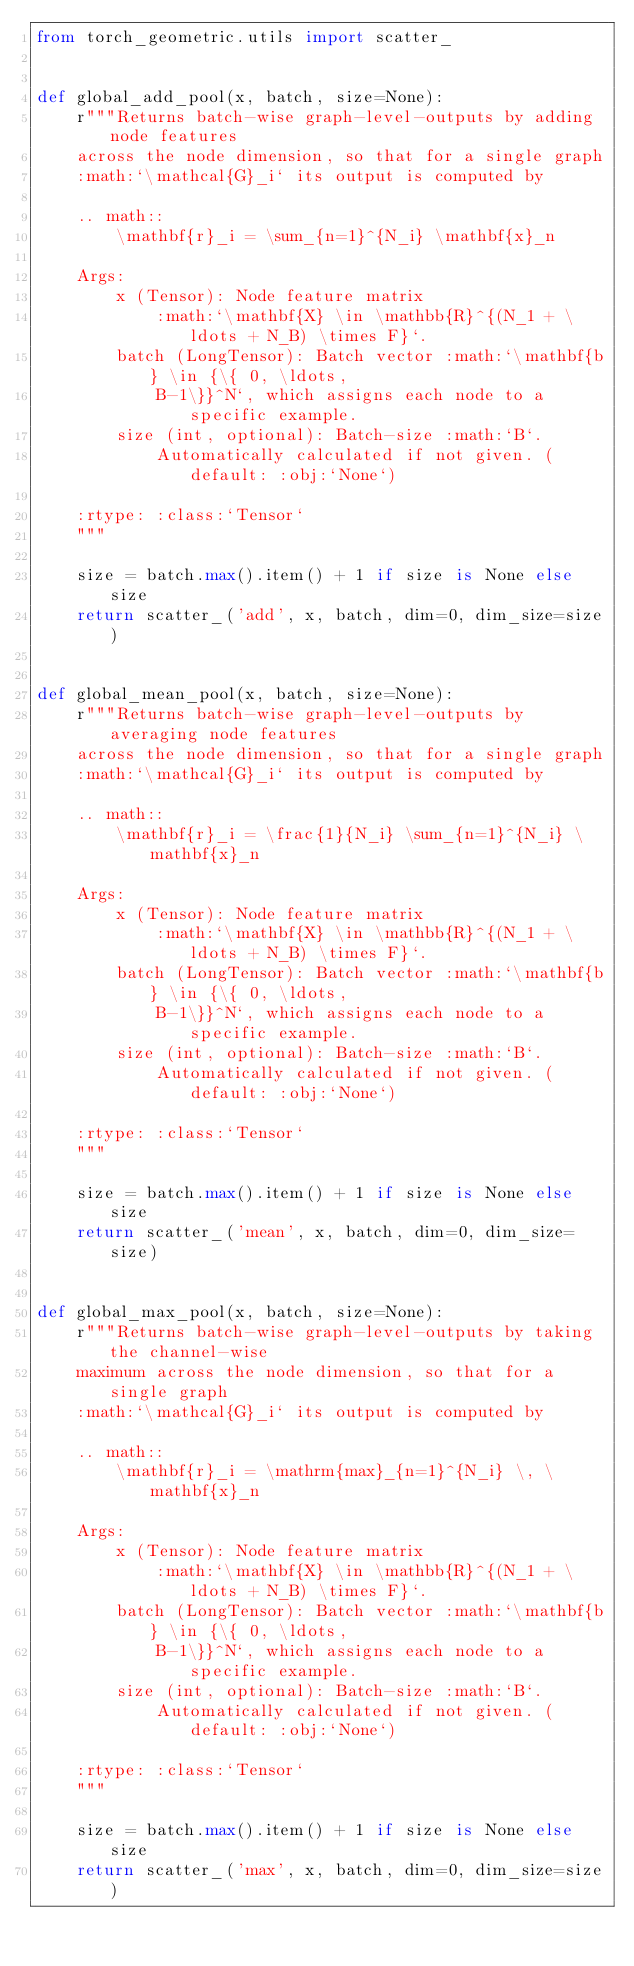Convert code to text. <code><loc_0><loc_0><loc_500><loc_500><_Python_>from torch_geometric.utils import scatter_


def global_add_pool(x, batch, size=None):
    r"""Returns batch-wise graph-level-outputs by adding node features
    across the node dimension, so that for a single graph
    :math:`\mathcal{G}_i` its output is computed by

    .. math::
        \mathbf{r}_i = \sum_{n=1}^{N_i} \mathbf{x}_n

    Args:
        x (Tensor): Node feature matrix
            :math:`\mathbf{X} \in \mathbb{R}^{(N_1 + \ldots + N_B) \times F}`.
        batch (LongTensor): Batch vector :math:`\mathbf{b} \in {\{ 0, \ldots,
            B-1\}}^N`, which assigns each node to a specific example.
        size (int, optional): Batch-size :math:`B`.
            Automatically calculated if not given. (default: :obj:`None`)

    :rtype: :class:`Tensor`
    """

    size = batch.max().item() + 1 if size is None else size
    return scatter_('add', x, batch, dim=0, dim_size=size)


def global_mean_pool(x, batch, size=None):
    r"""Returns batch-wise graph-level-outputs by averaging node features
    across the node dimension, so that for a single graph
    :math:`\mathcal{G}_i` its output is computed by

    .. math::
        \mathbf{r}_i = \frac{1}{N_i} \sum_{n=1}^{N_i} \mathbf{x}_n

    Args:
        x (Tensor): Node feature matrix
            :math:`\mathbf{X} \in \mathbb{R}^{(N_1 + \ldots + N_B) \times F}`.
        batch (LongTensor): Batch vector :math:`\mathbf{b} \in {\{ 0, \ldots,
            B-1\}}^N`, which assigns each node to a specific example.
        size (int, optional): Batch-size :math:`B`.
            Automatically calculated if not given. (default: :obj:`None`)

    :rtype: :class:`Tensor`
    """

    size = batch.max().item() + 1 if size is None else size
    return scatter_('mean', x, batch, dim=0, dim_size=size)


def global_max_pool(x, batch, size=None):
    r"""Returns batch-wise graph-level-outputs by taking the channel-wise
    maximum across the node dimension, so that for a single graph
    :math:`\mathcal{G}_i` its output is computed by

    .. math::
        \mathbf{r}_i = \mathrm{max}_{n=1}^{N_i} \, \mathbf{x}_n

    Args:
        x (Tensor): Node feature matrix
            :math:`\mathbf{X} \in \mathbb{R}^{(N_1 + \ldots + N_B) \times F}`.
        batch (LongTensor): Batch vector :math:`\mathbf{b} \in {\{ 0, \ldots,
            B-1\}}^N`, which assigns each node to a specific example.
        size (int, optional): Batch-size :math:`B`.
            Automatically calculated if not given. (default: :obj:`None`)

    :rtype: :class:`Tensor`
    """

    size = batch.max().item() + 1 if size is None else size
    return scatter_('max', x, batch, dim=0, dim_size=size)
</code> 